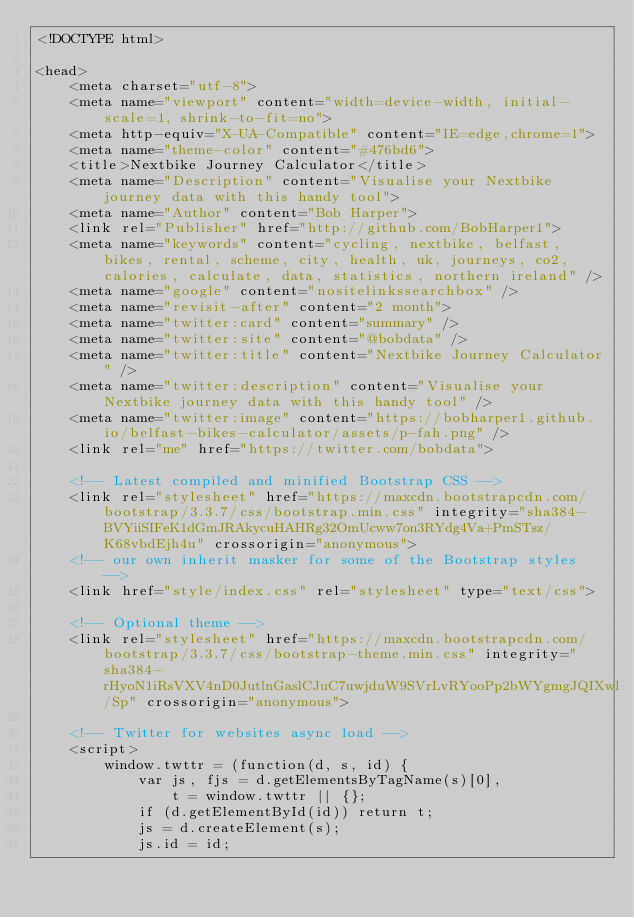Convert code to text. <code><loc_0><loc_0><loc_500><loc_500><_HTML_><!DOCTYPE html>

<head>
    <meta charset="utf-8">
    <meta name="viewport" content="width=device-width, initial-scale=1, shrink-to-fit=no">
    <meta http-equiv="X-UA-Compatible" content="IE=edge,chrome=1">
    <meta name="theme-color" content="#476bd6">
    <title>Nextbike Journey Calculator</title>
    <meta name="Description" content="Visualise your Nextbike journey data with this handy tool">
    <meta name="Author" content="Bob Harper">
    <link rel="Publisher" href="http://github.com/BobHarper1">
    <meta name="keywords" content="cycling, nextbike, belfast, bikes, rental, scheme, city, health, uk, journeys, co2, calories, calculate, data, statistics, northern ireland" />
    <meta name="google" content="nositelinkssearchbox" />
    <meta name="revisit-after" content="2 month">
    <meta name="twitter:card" content="summary" />
    <meta name="twitter:site" content="@bobdata" />
    <meta name="twitter:title" content="Nextbike Journey Calculator" />
    <meta name="twitter:description" content="Visualise your Nextbike journey data with this handy tool" />
    <meta name="twitter:image" content="https://bobharper1.github.io/belfast-bikes-calculator/assets/p-fah.png" />
    <link rel="me" href="https://twitter.com/bobdata">

    <!-- Latest compiled and minified Bootstrap CSS -->
    <link rel="stylesheet" href="https://maxcdn.bootstrapcdn.com/bootstrap/3.3.7/css/bootstrap.min.css" integrity="sha384-BVYiiSIFeK1dGmJRAkycuHAHRg32OmUcww7on3RYdg4Va+PmSTsz/K68vbdEjh4u" crossorigin="anonymous">
    <!-- our own inherit masker for some of the Bootstrap styles -->
    <link href="style/index.css" rel="stylesheet" type="text/css">

    <!-- Optional theme -->
    <link rel="stylesheet" href="https://maxcdn.bootstrapcdn.com/bootstrap/3.3.7/css/bootstrap-theme.min.css" integrity="sha384-rHyoN1iRsVXV4nD0JutlnGaslCJuC7uwjduW9SVrLvRYooPp2bWYgmgJQIXwl/Sp" crossorigin="anonymous">

    <!-- Twitter for websites async load -->
    <script>
        window.twttr = (function(d, s, id) {
            var js, fjs = d.getElementsByTagName(s)[0],
                t = window.twttr || {};
            if (d.getElementById(id)) return t;
            js = d.createElement(s);
            js.id = id;</code> 